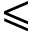<formula> <loc_0><loc_0><loc_500><loc_500>\leqslant</formula> 